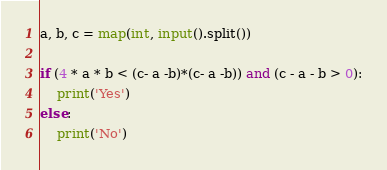<code> <loc_0><loc_0><loc_500><loc_500><_Python_>a, b, c = map(int, input().split())

if (4 * a * b < (c- a -b)*(c- a -b)) and (c - a - b > 0):
    print('Yes')
else:
    print('No')</code> 